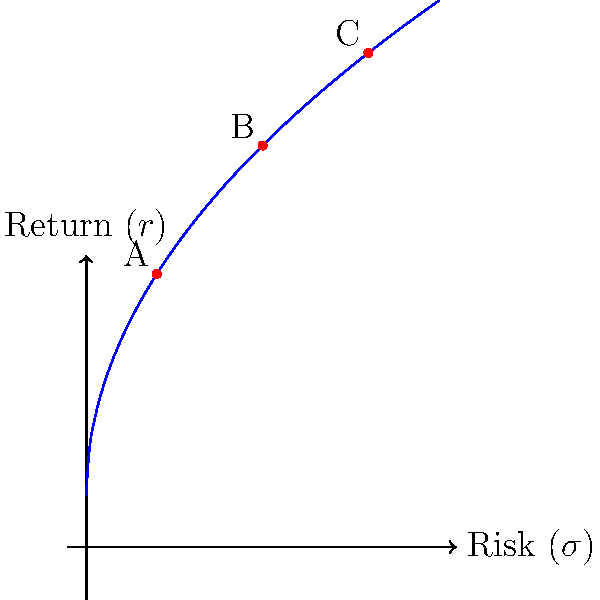Based on the efficient frontier graph shown, which investment option (A, B, or C) would you recommend to a client seeking a balanced approach between risk and return? Explain your reasoning considering the risk-return trade-off. To answer this question, we need to analyze the efficient frontier graph and understand the risk-return trade-off for each investment option:

1. The efficient frontier graph shows the optimal portfolios that offer the highest expected return for a given level of risk.

2. Points on the curve represent portfolios with different risk-return profiles:
   - Point A: Low risk, low return
   - Point B: Medium risk, medium return
   - Point C: High risk, high return

3. Risk-return trade-off:
   - As we move from A to C, both risk ($\sigma$) and expected return ($r$) increase.
   - The curve's shape indicates diminishing marginal returns: as risk increases, the additional return per unit of risk decreases.

4. Balanced approach:
   - A balanced approach seeks to optimize the risk-return trade-off.
   - It aims to achieve a reasonable return while keeping risk at a manageable level.

5. Analyzing the options:
   - A is too conservative, potentially missing out on significant returns.
   - C is too aggressive, exposing the client to unnecessary risk.
   - B offers a middle ground, providing a good balance between risk and return.

6. Recommendation:
   - Option B represents the best balance between risk and return.
   - It offers a higher return than A with a moderate increase in risk.
   - It avoids the excessive risk of C while still providing substantial returns.

Therefore, for a client seeking a balanced approach, investment option B would be the most appropriate recommendation.
Answer: Option B, as it offers the best balance between risk and return on the efficient frontier. 